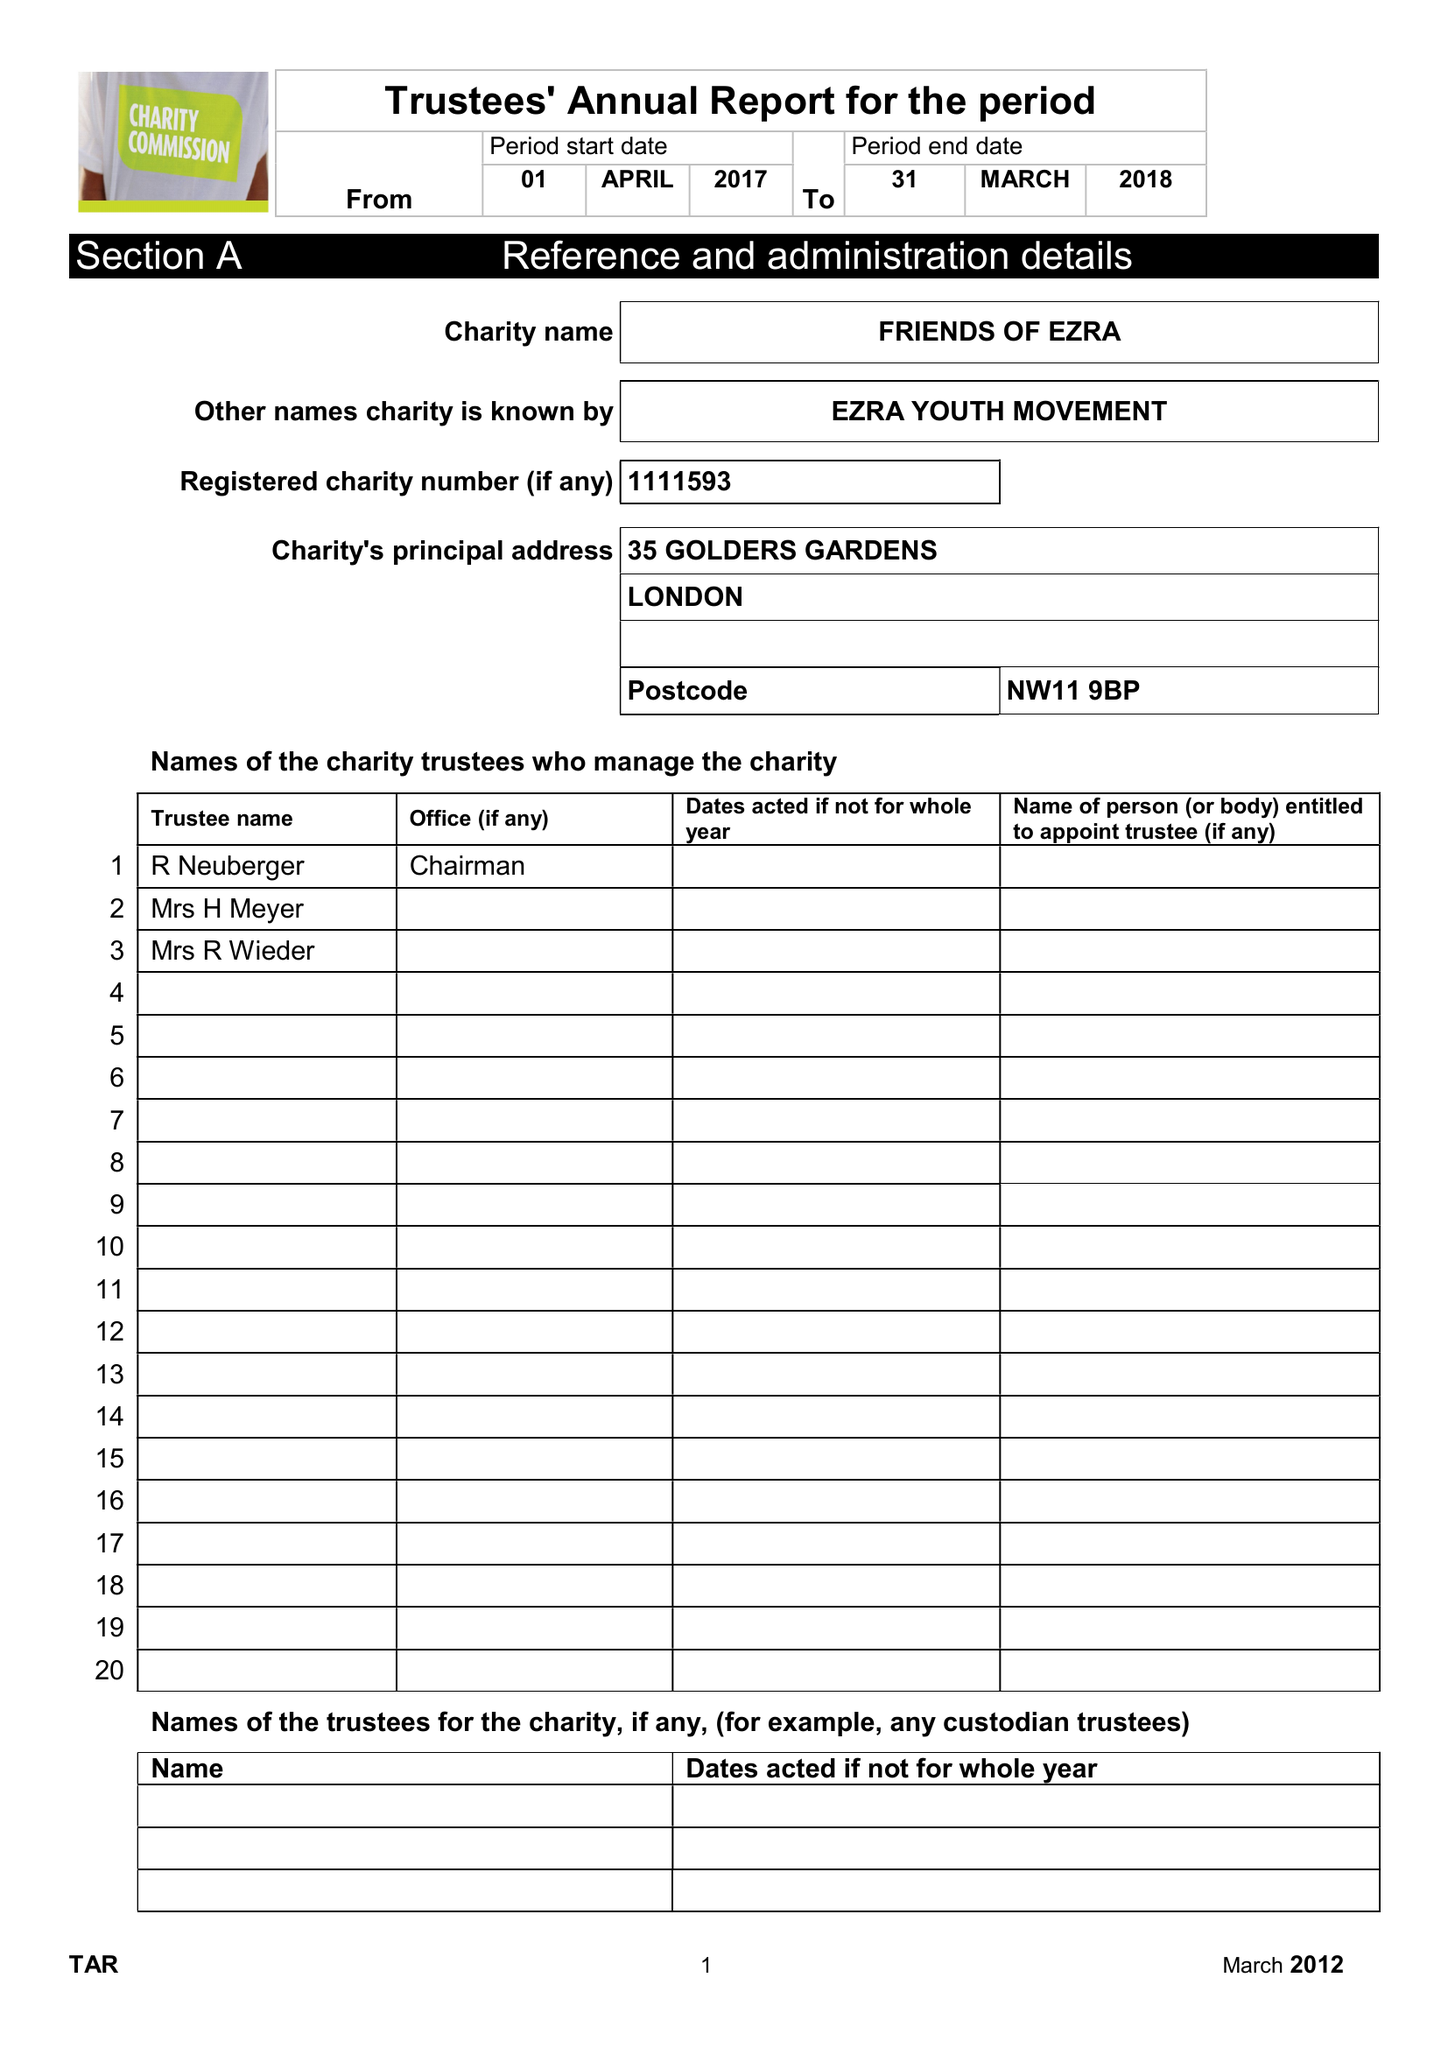What is the value for the report_date?
Answer the question using a single word or phrase. 2018-03-31 